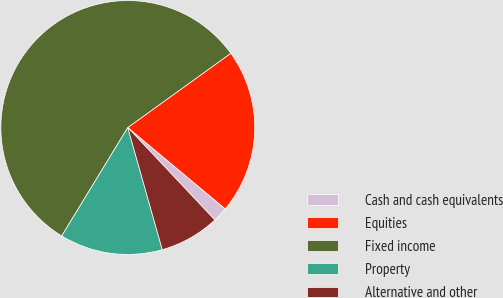Convert chart to OTSL. <chart><loc_0><loc_0><loc_500><loc_500><pie_chart><fcel>Cash and cash equivalents<fcel>Equities<fcel>Fixed income<fcel>Property<fcel>Alternative and other<nl><fcel>1.91%<fcel>21.01%<fcel>56.35%<fcel>13.09%<fcel>7.64%<nl></chart> 